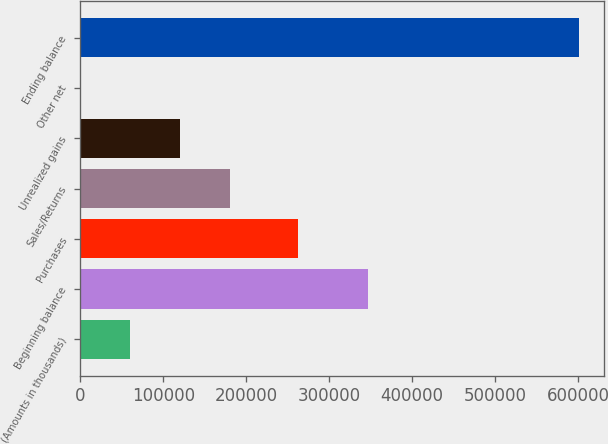<chart> <loc_0><loc_0><loc_500><loc_500><bar_chart><fcel>(Amounts in thousands)<fcel>Beginning balance<fcel>Purchases<fcel>Sales/Returns<fcel>Unrealized gains<fcel>Other net<fcel>Ending balance<nl><fcel>60336<fcel>346650<fcel>262251<fcel>180436<fcel>120386<fcel>286<fcel>600786<nl></chart> 